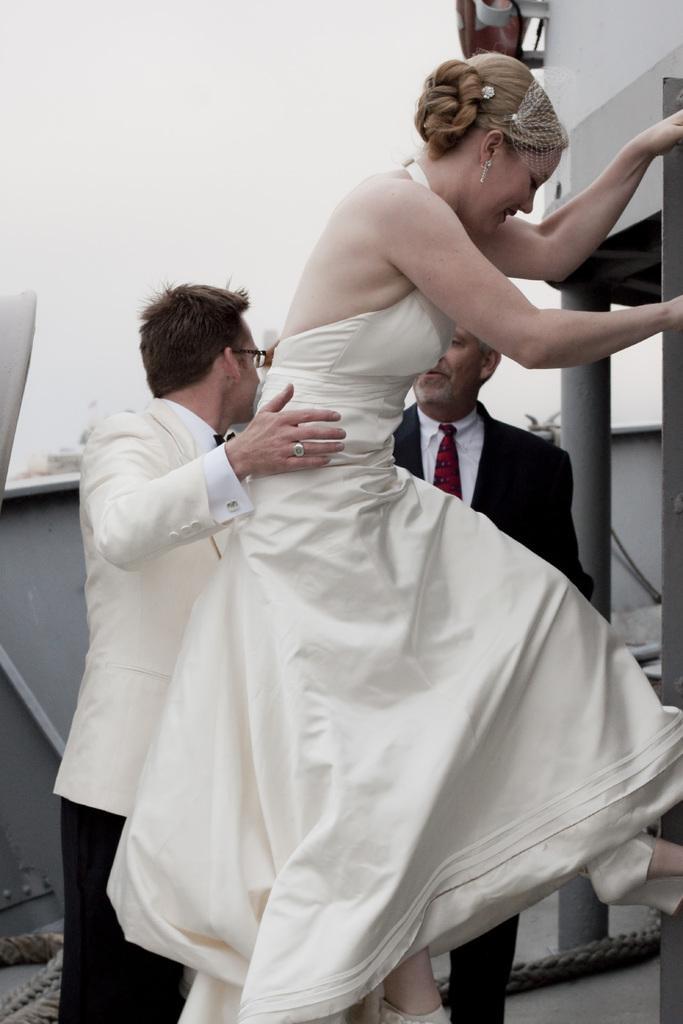How would you summarize this image in a sentence or two? Here we can see three people. This woman wore white dress. This man wore white suit. Another man wore black suit and tie. 